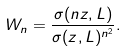<formula> <loc_0><loc_0><loc_500><loc_500>W _ { n } = \frac { \sigma ( n z , L ) } { \sigma ( z , L ) ^ { n ^ { 2 } } } .</formula> 